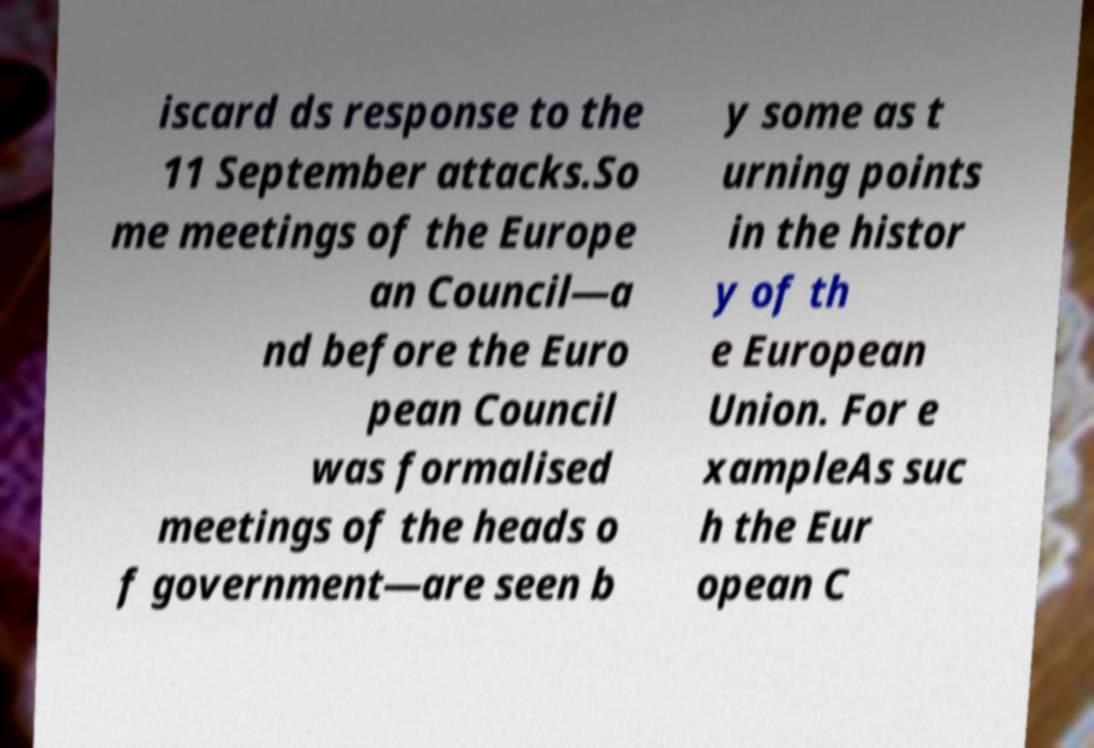Can you read and provide the text displayed in the image?This photo seems to have some interesting text. Can you extract and type it out for me? iscard ds response to the 11 September attacks.So me meetings of the Europe an Council—a nd before the Euro pean Council was formalised meetings of the heads o f government—are seen b y some as t urning points in the histor y of th e European Union. For e xampleAs suc h the Eur opean C 